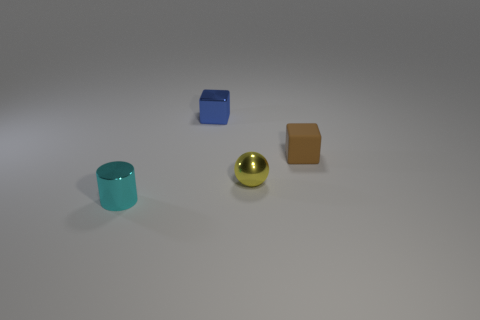Add 1 tiny green shiny balls. How many objects exist? 5 Subtract all cylinders. How many objects are left? 3 Subtract all brown blocks. How many blocks are left? 1 Add 4 tiny brown shiny balls. How many tiny brown shiny balls exist? 4 Subtract 1 cyan cylinders. How many objects are left? 3 Subtract all blue cubes. Subtract all purple balls. How many cubes are left? 1 Subtract all tiny green rubber objects. Subtract all tiny brown rubber things. How many objects are left? 3 Add 4 small rubber cubes. How many small rubber cubes are left? 5 